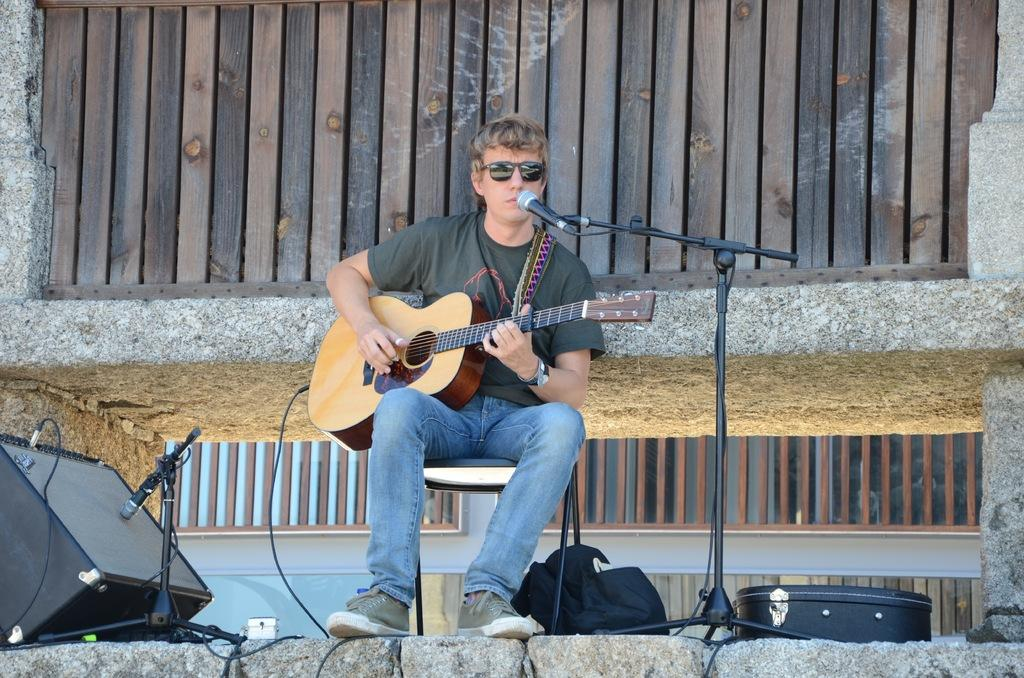Who is the main subject in the image? There is a man in the image. What is the man doing in the image? The man is sitting on a stool and playing the guitar. What is the man wearing in the image? The man is wearing black color spectacles. What is the man's opinion on the cause of the potato shortage in the image? There is no mention of a potato shortage or any discussion of opinions in the image. The man is simply playing the guitar while sitting on a stool. 